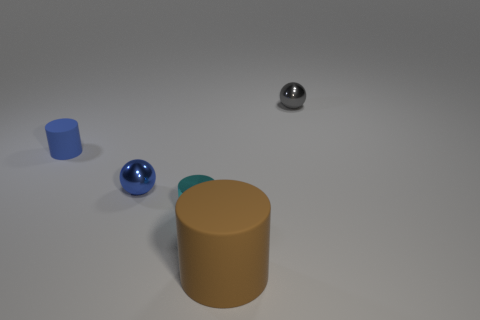Subtract all tiny cylinders. How many cylinders are left? 1 Subtract 1 cylinders. How many cylinders are left? 2 Add 3 large purple cylinders. How many objects exist? 8 Subtract all cylinders. How many objects are left? 2 Subtract all blue matte things. Subtract all blue things. How many objects are left? 2 Add 1 blue rubber objects. How many blue rubber objects are left? 2 Add 2 small yellow rubber blocks. How many small yellow rubber blocks exist? 2 Subtract 0 blue cubes. How many objects are left? 5 